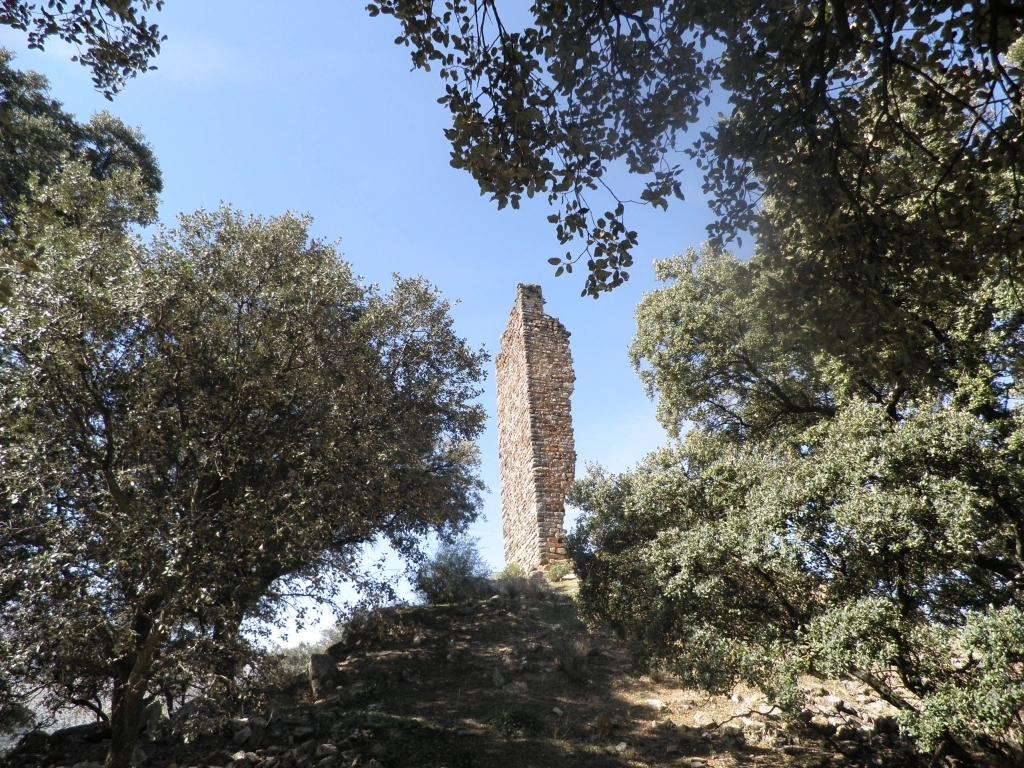What type of vegetation can be seen in the image? There are trees in the image. What type of structure is present in the image? There is a brick wall in the image. How would you describe the sky in the image? The sky is blue and cloudy in the image. What type of band is playing in the image? There is no band present in the image; it only features trees, a brick wall, and a blue and cloudy sky. Can you tell me how many nuts are visible in the image? There are no nuts present in the image. 